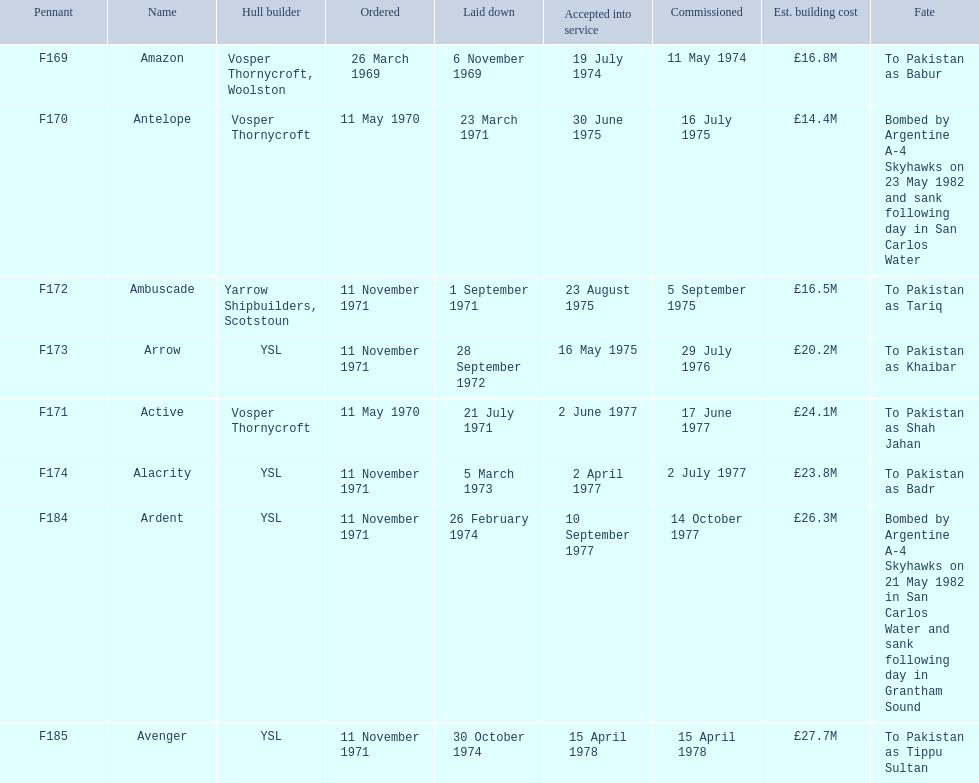What were the estimated building costs of the frigates? £16.8M, £14.4M, £16.5M, £20.2M, £24.1M, £23.8M, £26.3M, £27.7M. Would you mind parsing the complete table? {'header': ['Pennant', 'Name', 'Hull builder', 'Ordered', 'Laid down', 'Accepted into service', 'Commissioned', 'Est. building cost', 'Fate'], 'rows': [['F169', 'Amazon', 'Vosper Thornycroft, Woolston', '26 March 1969', '6 November 1969', '19 July 1974', '11 May 1974', '£16.8M', 'To Pakistan as Babur'], ['F170', 'Antelope', 'Vosper Thornycroft', '11 May 1970', '23 March 1971', '30 June 1975', '16 July 1975', '£14.4M', 'Bombed by Argentine A-4 Skyhawks on 23 May 1982 and sank following day in San Carlos Water'], ['F172', 'Ambuscade', 'Yarrow Shipbuilders, Scotstoun', '11 November 1971', '1 September 1971', '23 August 1975', '5 September 1975', '£16.5M', 'To Pakistan as Tariq'], ['F173', 'Arrow', 'YSL', '11 November 1971', '28 September 1972', '16 May 1975', '29 July 1976', '£20.2M', 'To Pakistan as Khaibar'], ['F171', 'Active', 'Vosper Thornycroft', '11 May 1970', '21 July 1971', '2 June 1977', '17 June 1977', '£24.1M', 'To Pakistan as Shah Jahan'], ['F174', 'Alacrity', 'YSL', '11 November 1971', '5 March 1973', '2 April 1977', '2 July 1977', '£23.8M', 'To Pakistan as Badr'], ['F184', 'Ardent', 'YSL', '11 November 1971', '26 February 1974', '10 September 1977', '14 October 1977', '£26.3M', 'Bombed by Argentine A-4 Skyhawks on 21 May 1982 in San Carlos Water and sank following day in Grantham Sound'], ['F185', 'Avenger', 'YSL', '11 November 1971', '30 October 1974', '15 April 1978', '15 April 1978', '£27.7M', 'To Pakistan as Tippu Sultan']]} Which of these is the largest? £27.7M. What ship name does that correspond to? Avenger. 